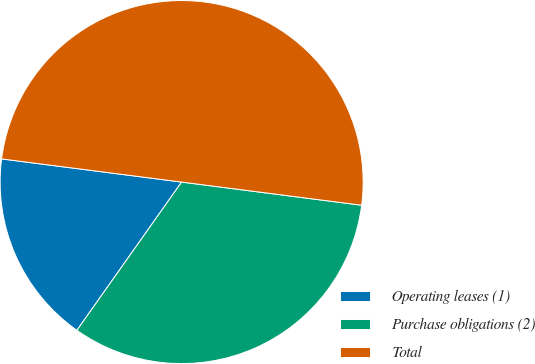Convert chart. <chart><loc_0><loc_0><loc_500><loc_500><pie_chart><fcel>Operating leases (1)<fcel>Purchase obligations (2)<fcel>Total<nl><fcel>17.25%<fcel>32.75%<fcel>50.0%<nl></chart> 